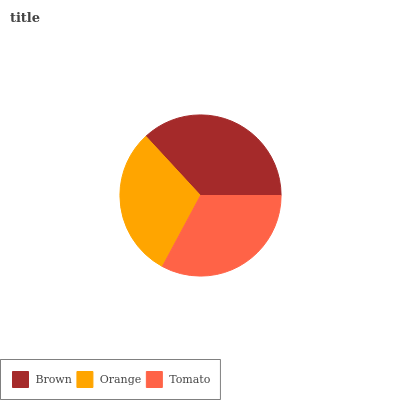Is Orange the minimum?
Answer yes or no. Yes. Is Brown the maximum?
Answer yes or no. Yes. Is Tomato the minimum?
Answer yes or no. No. Is Tomato the maximum?
Answer yes or no. No. Is Tomato greater than Orange?
Answer yes or no. Yes. Is Orange less than Tomato?
Answer yes or no. Yes. Is Orange greater than Tomato?
Answer yes or no. No. Is Tomato less than Orange?
Answer yes or no. No. Is Tomato the high median?
Answer yes or no. Yes. Is Tomato the low median?
Answer yes or no. Yes. Is Orange the high median?
Answer yes or no. No. Is Orange the low median?
Answer yes or no. No. 